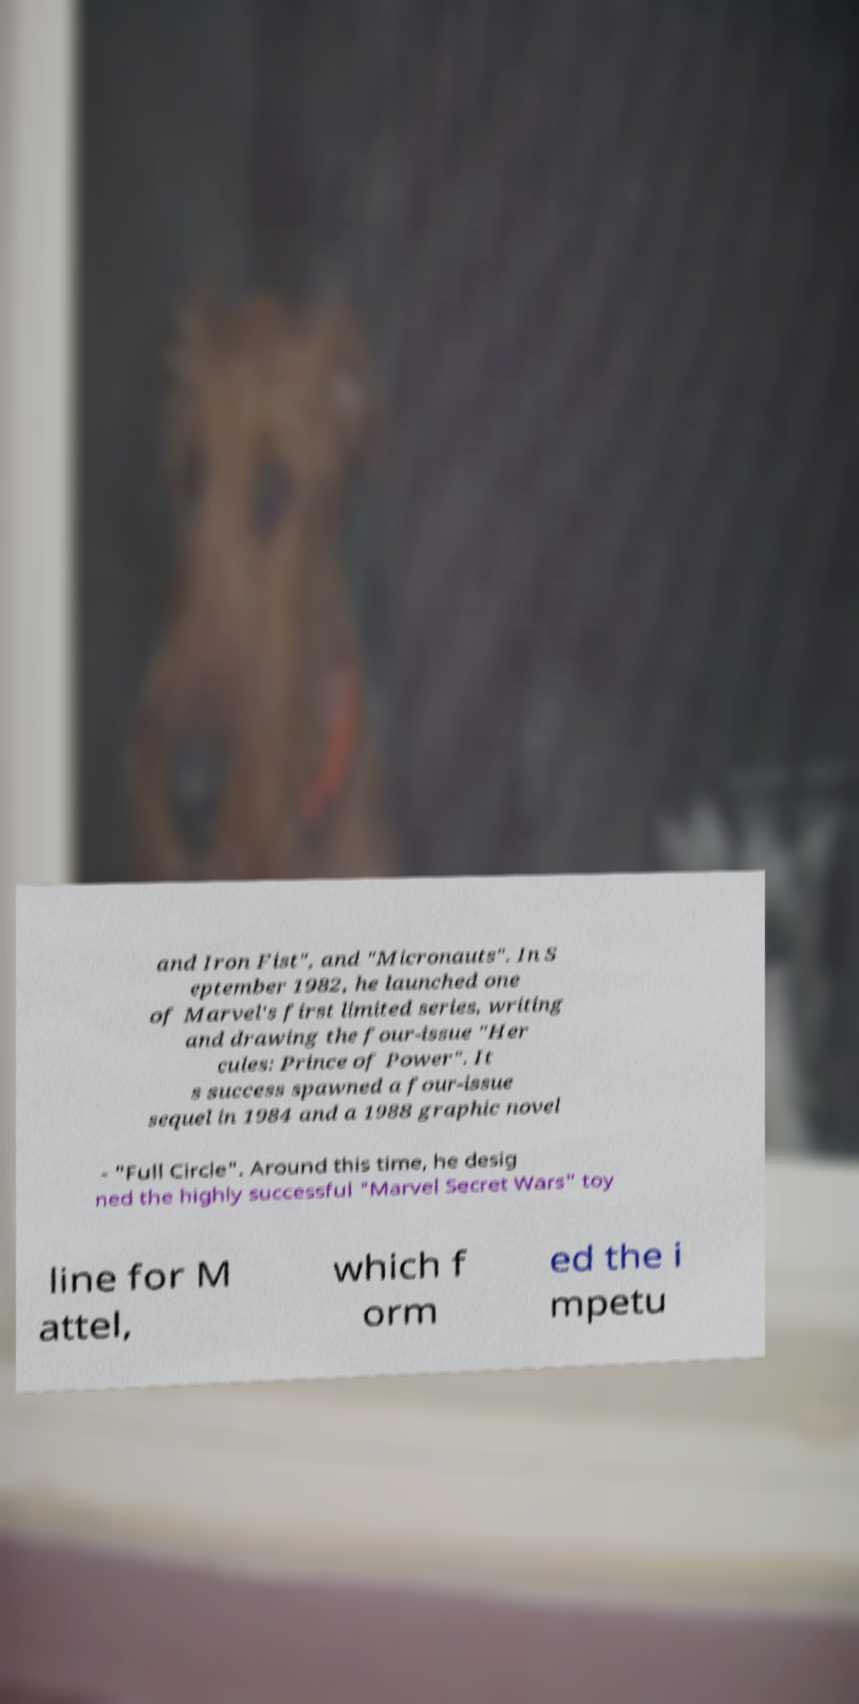Can you read and provide the text displayed in the image?This photo seems to have some interesting text. Can you extract and type it out for me? and Iron Fist", and "Micronauts". In S eptember 1982, he launched one of Marvel's first limited series, writing and drawing the four-issue "Her cules: Prince of Power". It s success spawned a four-issue sequel in 1984 and a 1988 graphic novel - "Full Circle". Around this time, he desig ned the highly successful "Marvel Secret Wars" toy line for M attel, which f orm ed the i mpetu 